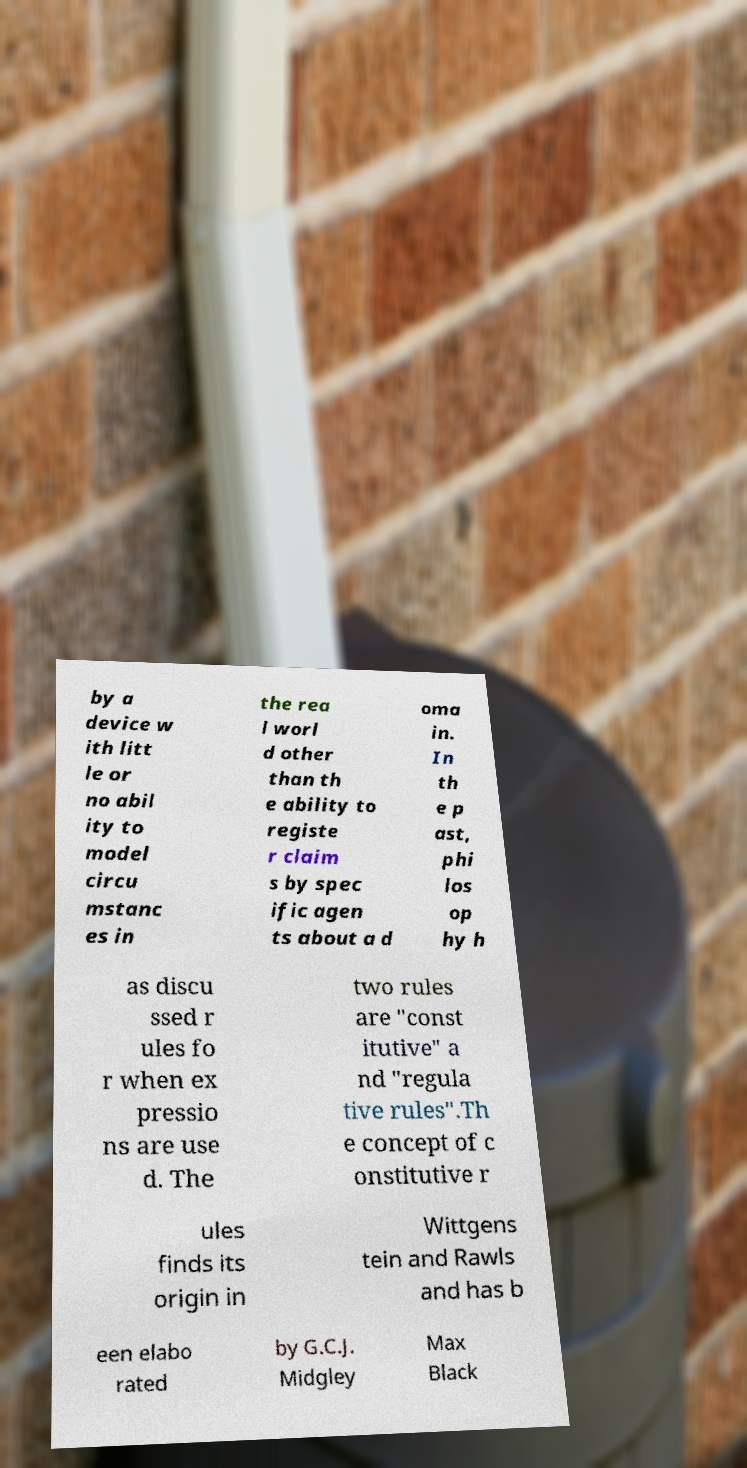What messages or text are displayed in this image? I need them in a readable, typed format. by a device w ith litt le or no abil ity to model circu mstanc es in the rea l worl d other than th e ability to registe r claim s by spec ific agen ts about a d oma in. In th e p ast, phi los op hy h as discu ssed r ules fo r when ex pressio ns are use d. The two rules are "const itutive" a nd "regula tive rules".Th e concept of c onstitutive r ules finds its origin in Wittgens tein and Rawls and has b een elabo rated by G.C.J. Midgley Max Black 